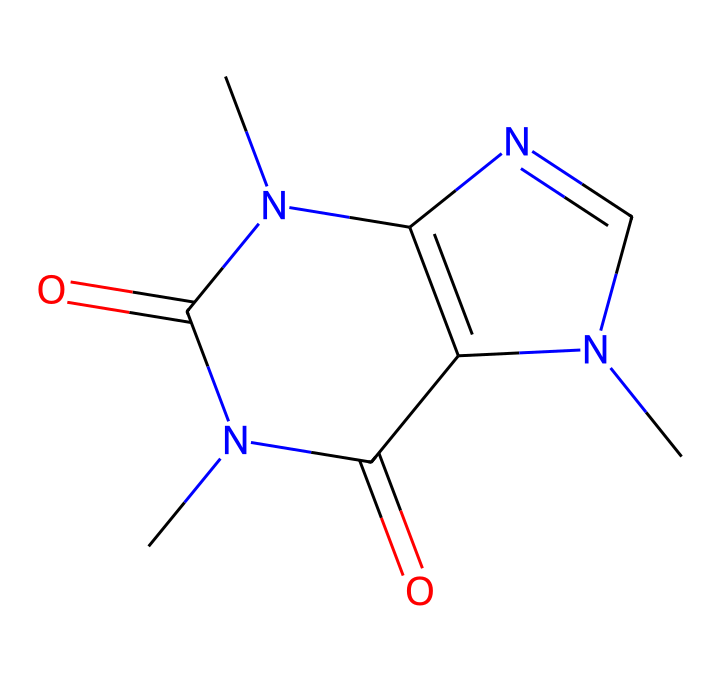What is the molecular formula for caffeine? By analyzing the structure represented by the SMILES notation, we can count the number of carbon, hydrogen, nitrogen, and oxygen atoms present. The structure indicates there are 8 carbon atoms (C), 10 hydrogen atoms (H), 4 nitrogen atoms (N), and 2 oxygen atoms (O), forming the molecular formula C8H10N4O2.
Answer: C8H10N4O2 How many nitrogen atoms are in caffeine? The SMILES representation contains the element 'N' several times, indicating nitrogen atoms. Counting them, we find there are four nitrogen atoms present in the chemical structure.
Answer: 4 What type of chemical compound is caffeine classified as? Caffeine is classified as an alkaloid due to the presence of nitrogen atoms in its structure, which gives it psychoactive properties. Alkaloids typically exhibit similar traits and are derived from natural sources like plants.
Answer: alkaloid What is the number of rings in the caffeine structure? By visualizing the arrangement of the atoms and bonds in the chemical structure, we can see that caffeine contains two fused ring systems, which can be identified as a purine derivative. Counting these structures reveals there are two rings present.
Answer: 2 Does caffeine contain any double bonds? Analyzing the SMILES representation, we observe the presence of the '=' symbol, which indicates double bonds within the chemical structure. After checking the relevant carbon and nitrogen atoms connected by double bonds, we confirm there are two double bonds in the caffeine molecule.
Answer: 2 What is the primary effect of caffeine on the human body? Caffeine primarily acts as a stimulant, which enhances alertness and reduces fatigue by blocking the adenosine receptors in the brain. This stimulation is mainly due to its alkaloid nature and interaction with neurotransmitter systems.
Answer: stimulant 